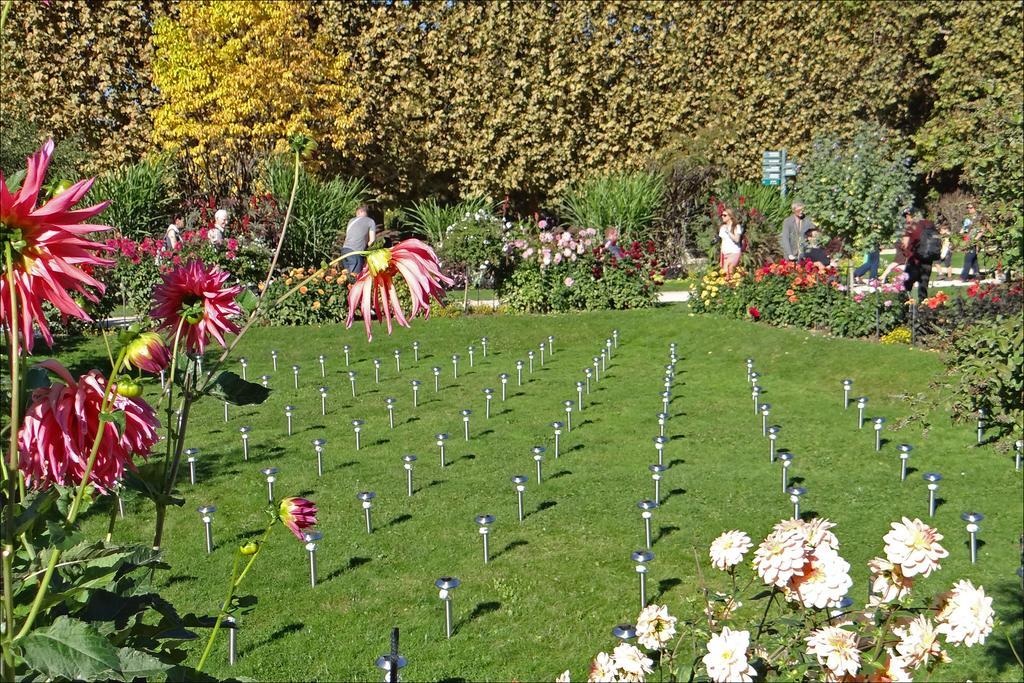Could you give a brief overview of what you see in this image? In this picture we can see flowers, poles, grass, trees, boards and a group of people walking on the ground. 